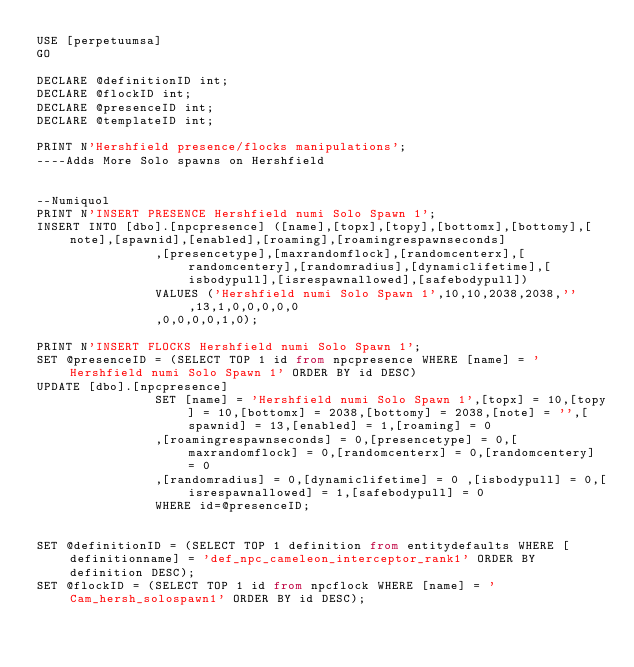<code> <loc_0><loc_0><loc_500><loc_500><_SQL_>USE [perpetuumsa]
GO

DECLARE @definitionID int;
DECLARE @flockID int;
DECLARE @presenceID int;
DECLARE @templateID int;

PRINT N'Hershfield presence/flocks manipulations';
----Adds More Solo spawns on Hershfield


--Numiquol
PRINT N'INSERT PRESENCE Hershfield numi Solo Spawn 1';
INSERT INTO [dbo].[npcpresence] ([name],[topx],[topy],[bottomx],[bottomy],[note],[spawnid],[enabled],[roaming],[roamingrespawnseconds]
                ,[presencetype],[maxrandomflock],[randomcenterx],[randomcentery],[randomradius],[dynamiclifetime],[isbodypull],[isrespawnallowed],[safebodypull])
                VALUES ('Hershfield numi Solo Spawn 1',10,10,2038,2038,'',13,1,0,0,0,0,0
			    ,0,0,0,0,1,0);

PRINT N'INSERT FLOCKS Hershfield numi Solo Spawn 1';
SET @presenceID = (SELECT TOP 1 id from npcpresence WHERE [name] = 'Hershfield numi Solo Spawn 1' ORDER BY id DESC)
UPDATE [dbo].[npcpresence]
                SET [name] = 'Hershfield numi Solo Spawn 1',[topx] = 10,[topy] = 10,[bottomx] = 2038,[bottomy] = 2038,[note] = '',[spawnid] = 13,[enabled] = 1,[roaming] = 0
                ,[roamingrespawnseconds] = 0,[presencetype] = 0,[maxrandomflock] = 0,[randomcenterx] = 0,[randomcentery] = 0
                ,[randomradius] = 0,[dynamiclifetime] = 0 ,[isbodypull] = 0,[isrespawnallowed] = 1,[safebodypull] = 0
                WHERE id=@presenceID;


SET @definitionID = (SELECT TOP 1 definition from entitydefaults WHERE [definitionname] = 'def_npc_cameleon_interceptor_rank1' ORDER BY definition DESC);
SET @flockID = (SELECT TOP 1 id from npcflock WHERE [name] = 'Cam_hersh_solospawn1' ORDER BY id DESC);</code> 